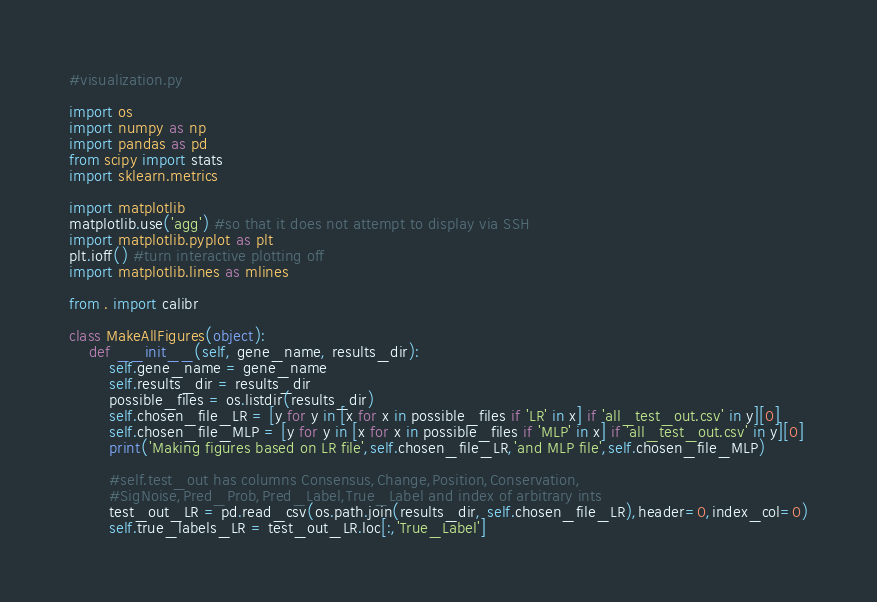Convert code to text. <code><loc_0><loc_0><loc_500><loc_500><_Python_>#visualization.py

import os
import numpy as np
import pandas as pd
from scipy import stats
import sklearn.metrics

import matplotlib
matplotlib.use('agg') #so that it does not attempt to display via SSH
import matplotlib.pyplot as plt
plt.ioff() #turn interactive plotting off
import matplotlib.lines as mlines

from . import calibr

class MakeAllFigures(object):
    def __init__(self, gene_name, results_dir):
        self.gene_name = gene_name
        self.results_dir = results_dir
        possible_files = os.listdir(results_dir)
        self.chosen_file_LR = [y for y in [x for x in possible_files if 'LR' in x] if 'all_test_out.csv' in y][0]
        self.chosen_file_MLP = [y for y in [x for x in possible_files if 'MLP' in x] if 'all_test_out.csv' in y][0]
        print('Making figures based on LR file',self.chosen_file_LR,'and MLP file',self.chosen_file_MLP)
                
        #self.test_out has columns Consensus,Change,Position,Conservation,
        #SigNoise,Pred_Prob,Pred_Label,True_Label and index of arbitrary ints
        test_out_LR = pd.read_csv(os.path.join(results_dir, self.chosen_file_LR),header=0,index_col=0)
        self.true_labels_LR = test_out_LR.loc[:,'True_Label']</code> 